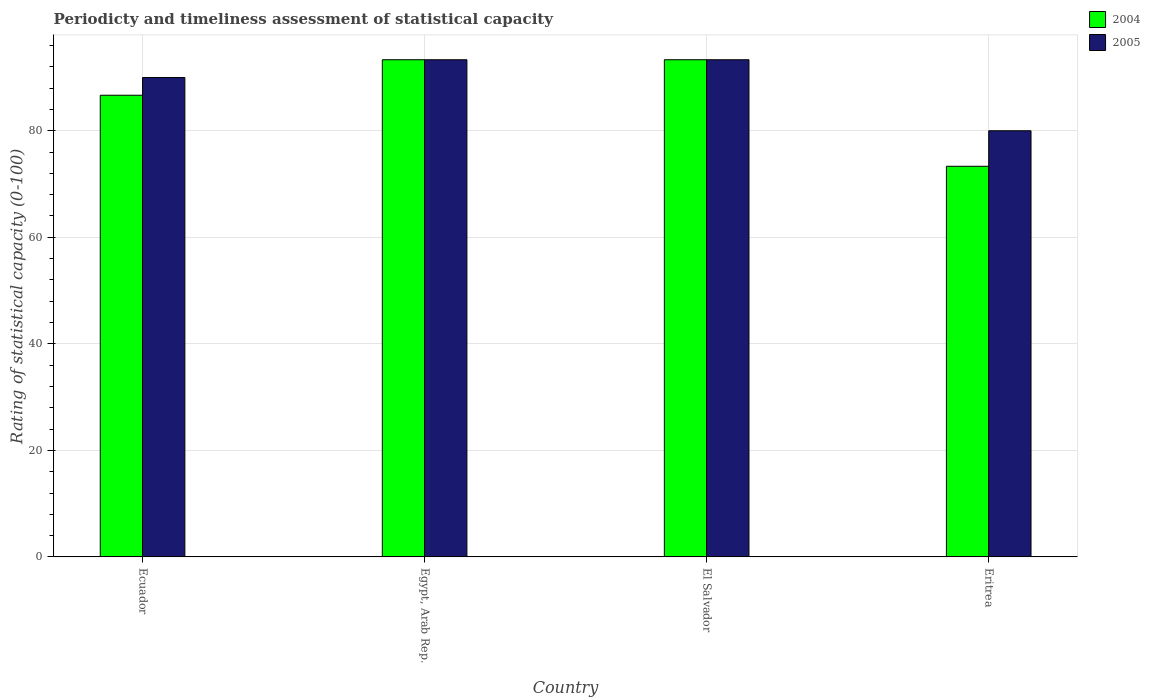How many groups of bars are there?
Your response must be concise. 4. Are the number of bars on each tick of the X-axis equal?
Offer a very short reply. Yes. How many bars are there on the 3rd tick from the right?
Make the answer very short. 2. What is the label of the 1st group of bars from the left?
Make the answer very short. Ecuador. What is the rating of statistical capacity in 2004 in Egypt, Arab Rep.?
Provide a succinct answer. 93.33. Across all countries, what is the maximum rating of statistical capacity in 2005?
Make the answer very short. 93.33. In which country was the rating of statistical capacity in 2004 maximum?
Give a very brief answer. Egypt, Arab Rep. In which country was the rating of statistical capacity in 2004 minimum?
Your response must be concise. Eritrea. What is the total rating of statistical capacity in 2005 in the graph?
Your response must be concise. 356.67. What is the difference between the rating of statistical capacity in 2004 in Ecuador and the rating of statistical capacity in 2005 in Eritrea?
Your answer should be compact. 6.67. What is the average rating of statistical capacity in 2004 per country?
Your answer should be very brief. 86.67. What is the difference between the rating of statistical capacity of/in 2004 and rating of statistical capacity of/in 2005 in Ecuador?
Give a very brief answer. -3.33. Is the difference between the rating of statistical capacity in 2004 in Egypt, Arab Rep. and Eritrea greater than the difference between the rating of statistical capacity in 2005 in Egypt, Arab Rep. and Eritrea?
Offer a very short reply. Yes. What is the difference between the highest and the second highest rating of statistical capacity in 2005?
Offer a very short reply. -3.33. In how many countries, is the rating of statistical capacity in 2005 greater than the average rating of statistical capacity in 2005 taken over all countries?
Your answer should be compact. 3. What does the 1st bar from the right in Ecuador represents?
Provide a short and direct response. 2005. How many bars are there?
Give a very brief answer. 8. Are all the bars in the graph horizontal?
Make the answer very short. No. How many countries are there in the graph?
Your response must be concise. 4. What is the difference between two consecutive major ticks on the Y-axis?
Give a very brief answer. 20. Are the values on the major ticks of Y-axis written in scientific E-notation?
Ensure brevity in your answer.  No. Does the graph contain any zero values?
Keep it short and to the point. No. Does the graph contain grids?
Provide a succinct answer. Yes. Where does the legend appear in the graph?
Ensure brevity in your answer.  Top right. How many legend labels are there?
Give a very brief answer. 2. What is the title of the graph?
Offer a very short reply. Periodicty and timeliness assessment of statistical capacity. Does "1969" appear as one of the legend labels in the graph?
Provide a succinct answer. No. What is the label or title of the X-axis?
Your answer should be very brief. Country. What is the label or title of the Y-axis?
Offer a very short reply. Rating of statistical capacity (0-100). What is the Rating of statistical capacity (0-100) of 2004 in Ecuador?
Your answer should be very brief. 86.67. What is the Rating of statistical capacity (0-100) in 2005 in Ecuador?
Give a very brief answer. 90. What is the Rating of statistical capacity (0-100) in 2004 in Egypt, Arab Rep.?
Keep it short and to the point. 93.33. What is the Rating of statistical capacity (0-100) in 2005 in Egypt, Arab Rep.?
Ensure brevity in your answer.  93.33. What is the Rating of statistical capacity (0-100) of 2004 in El Salvador?
Give a very brief answer. 93.33. What is the Rating of statistical capacity (0-100) of 2005 in El Salvador?
Your answer should be very brief. 93.33. What is the Rating of statistical capacity (0-100) of 2004 in Eritrea?
Your response must be concise. 73.33. Across all countries, what is the maximum Rating of statistical capacity (0-100) in 2004?
Offer a terse response. 93.33. Across all countries, what is the maximum Rating of statistical capacity (0-100) in 2005?
Your response must be concise. 93.33. Across all countries, what is the minimum Rating of statistical capacity (0-100) of 2004?
Give a very brief answer. 73.33. Across all countries, what is the minimum Rating of statistical capacity (0-100) in 2005?
Your answer should be compact. 80. What is the total Rating of statistical capacity (0-100) of 2004 in the graph?
Make the answer very short. 346.67. What is the total Rating of statistical capacity (0-100) of 2005 in the graph?
Keep it short and to the point. 356.67. What is the difference between the Rating of statistical capacity (0-100) in 2004 in Ecuador and that in Egypt, Arab Rep.?
Offer a terse response. -6.67. What is the difference between the Rating of statistical capacity (0-100) of 2004 in Ecuador and that in El Salvador?
Your response must be concise. -6.67. What is the difference between the Rating of statistical capacity (0-100) of 2004 in Ecuador and that in Eritrea?
Provide a short and direct response. 13.33. What is the difference between the Rating of statistical capacity (0-100) in 2005 in Egypt, Arab Rep. and that in El Salvador?
Offer a very short reply. 0. What is the difference between the Rating of statistical capacity (0-100) of 2004 in Egypt, Arab Rep. and that in Eritrea?
Offer a terse response. 20. What is the difference between the Rating of statistical capacity (0-100) of 2005 in Egypt, Arab Rep. and that in Eritrea?
Ensure brevity in your answer.  13.33. What is the difference between the Rating of statistical capacity (0-100) of 2004 in El Salvador and that in Eritrea?
Provide a short and direct response. 20. What is the difference between the Rating of statistical capacity (0-100) in 2005 in El Salvador and that in Eritrea?
Make the answer very short. 13.33. What is the difference between the Rating of statistical capacity (0-100) in 2004 in Ecuador and the Rating of statistical capacity (0-100) in 2005 in Egypt, Arab Rep.?
Keep it short and to the point. -6.67. What is the difference between the Rating of statistical capacity (0-100) in 2004 in Ecuador and the Rating of statistical capacity (0-100) in 2005 in El Salvador?
Offer a terse response. -6.67. What is the difference between the Rating of statistical capacity (0-100) in 2004 in Egypt, Arab Rep. and the Rating of statistical capacity (0-100) in 2005 in El Salvador?
Your answer should be very brief. 0. What is the difference between the Rating of statistical capacity (0-100) of 2004 in Egypt, Arab Rep. and the Rating of statistical capacity (0-100) of 2005 in Eritrea?
Give a very brief answer. 13.33. What is the difference between the Rating of statistical capacity (0-100) of 2004 in El Salvador and the Rating of statistical capacity (0-100) of 2005 in Eritrea?
Keep it short and to the point. 13.33. What is the average Rating of statistical capacity (0-100) in 2004 per country?
Make the answer very short. 86.67. What is the average Rating of statistical capacity (0-100) of 2005 per country?
Offer a very short reply. 89.17. What is the difference between the Rating of statistical capacity (0-100) in 2004 and Rating of statistical capacity (0-100) in 2005 in El Salvador?
Offer a terse response. 0. What is the difference between the Rating of statistical capacity (0-100) of 2004 and Rating of statistical capacity (0-100) of 2005 in Eritrea?
Make the answer very short. -6.67. What is the ratio of the Rating of statistical capacity (0-100) in 2004 in Ecuador to that in Eritrea?
Your response must be concise. 1.18. What is the ratio of the Rating of statistical capacity (0-100) in 2005 in Ecuador to that in Eritrea?
Offer a very short reply. 1.12. What is the ratio of the Rating of statistical capacity (0-100) in 2005 in Egypt, Arab Rep. to that in El Salvador?
Your answer should be very brief. 1. What is the ratio of the Rating of statistical capacity (0-100) in 2004 in Egypt, Arab Rep. to that in Eritrea?
Your answer should be very brief. 1.27. What is the ratio of the Rating of statistical capacity (0-100) in 2004 in El Salvador to that in Eritrea?
Provide a short and direct response. 1.27. What is the difference between the highest and the second highest Rating of statistical capacity (0-100) of 2004?
Provide a succinct answer. 0. What is the difference between the highest and the second highest Rating of statistical capacity (0-100) of 2005?
Keep it short and to the point. 0. What is the difference between the highest and the lowest Rating of statistical capacity (0-100) of 2005?
Offer a very short reply. 13.33. 